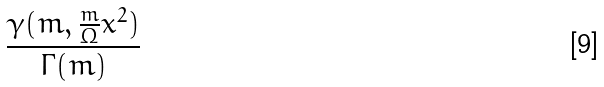Convert formula to latex. <formula><loc_0><loc_0><loc_500><loc_500>\frac { \gamma ( m , \frac { m } { \Omega } x ^ { 2 } ) } { \Gamma ( m ) }</formula> 